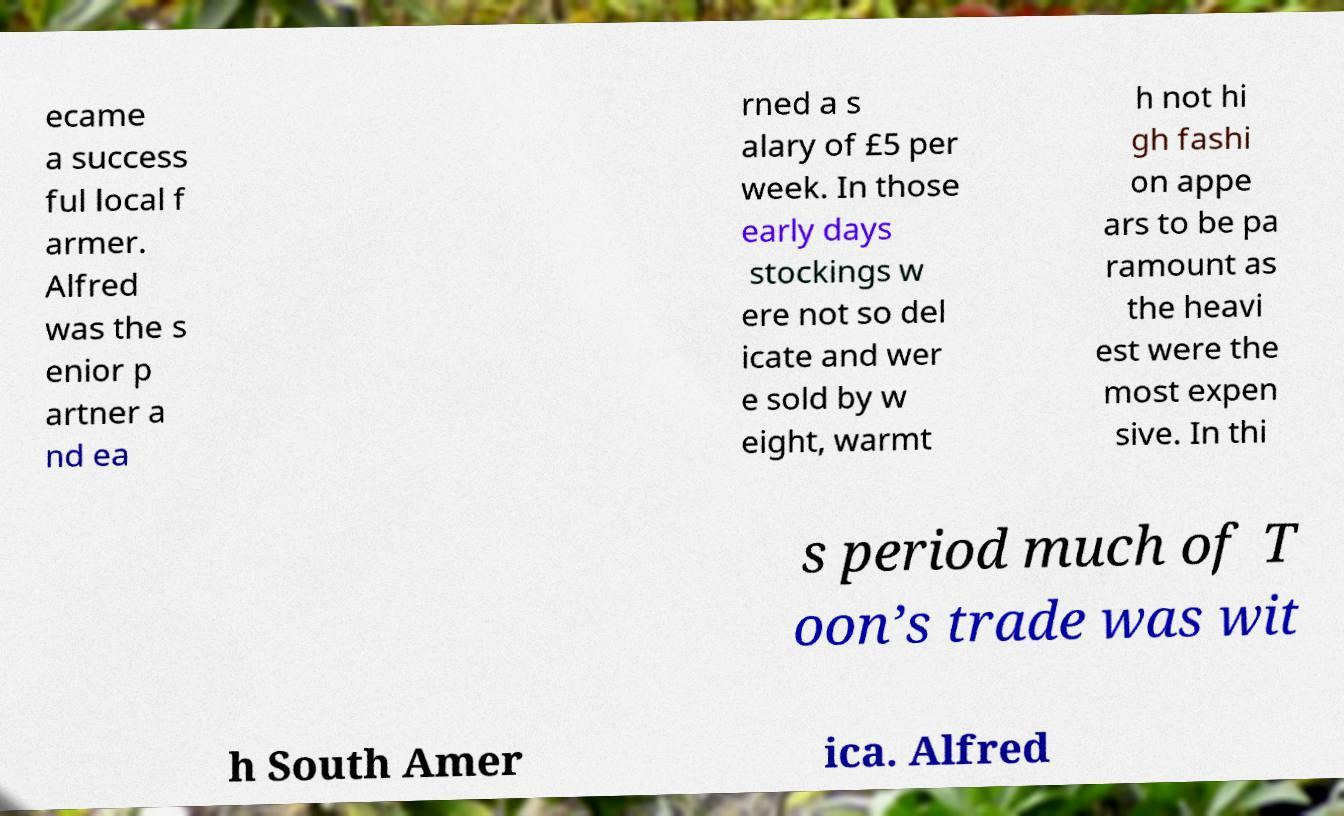There's text embedded in this image that I need extracted. Can you transcribe it verbatim? ecame a success ful local f armer. Alfred was the s enior p artner a nd ea rned a s alary of £5 per week. In those early days stockings w ere not so del icate and wer e sold by w eight, warmt h not hi gh fashi on appe ars to be pa ramount as the heavi est were the most expen sive. In thi s period much of T oon’s trade was wit h South Amer ica. Alfred 